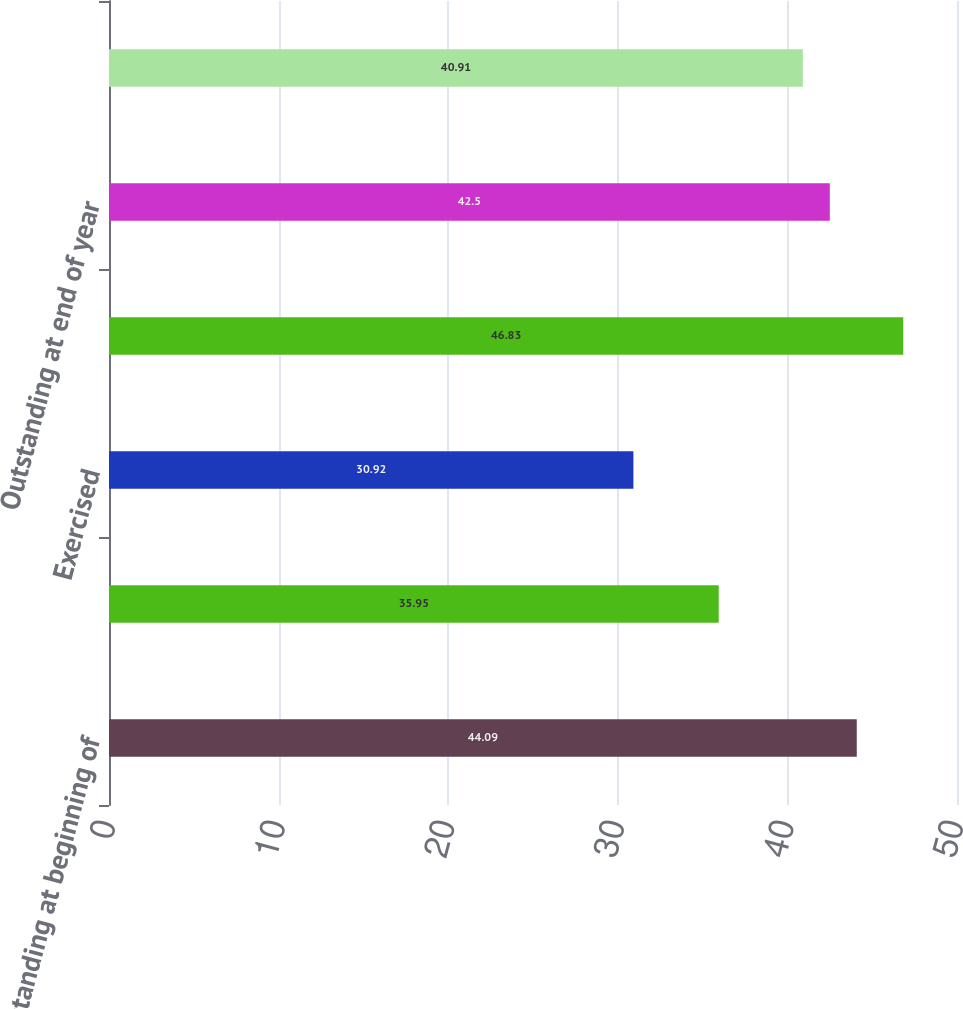Convert chart. <chart><loc_0><loc_0><loc_500><loc_500><bar_chart><fcel>Outstanding at beginning of<fcel>Granted<fcel>Exercised<fcel>Forfeited<fcel>Outstanding at end of year<fcel>Options exercisable at<nl><fcel>44.09<fcel>35.95<fcel>30.92<fcel>46.83<fcel>42.5<fcel>40.91<nl></chart> 